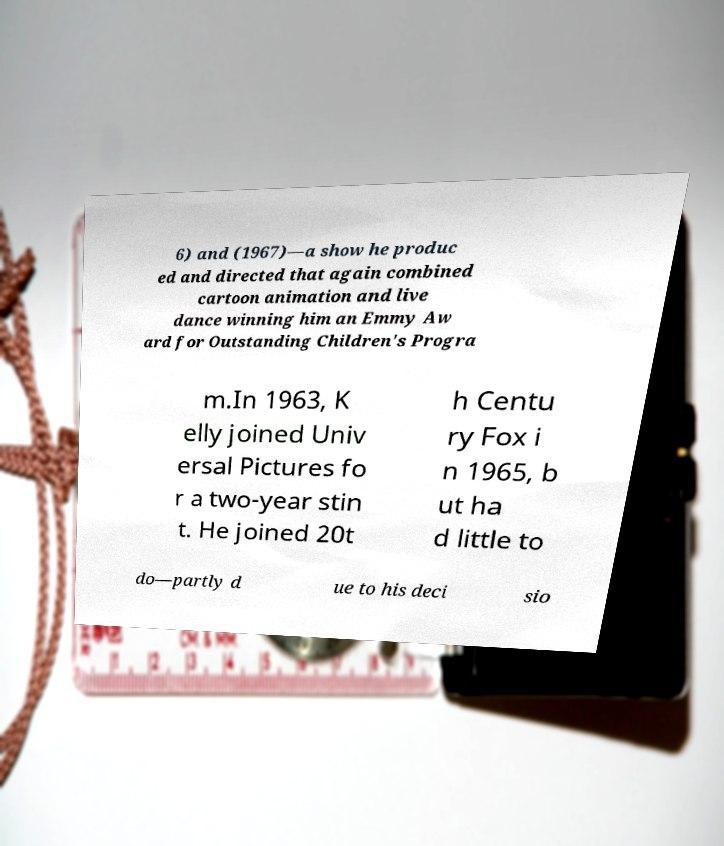There's text embedded in this image that I need extracted. Can you transcribe it verbatim? 6) and (1967)—a show he produc ed and directed that again combined cartoon animation and live dance winning him an Emmy Aw ard for Outstanding Children's Progra m.In 1963, K elly joined Univ ersal Pictures fo r a two-year stin t. He joined 20t h Centu ry Fox i n 1965, b ut ha d little to do—partly d ue to his deci sio 